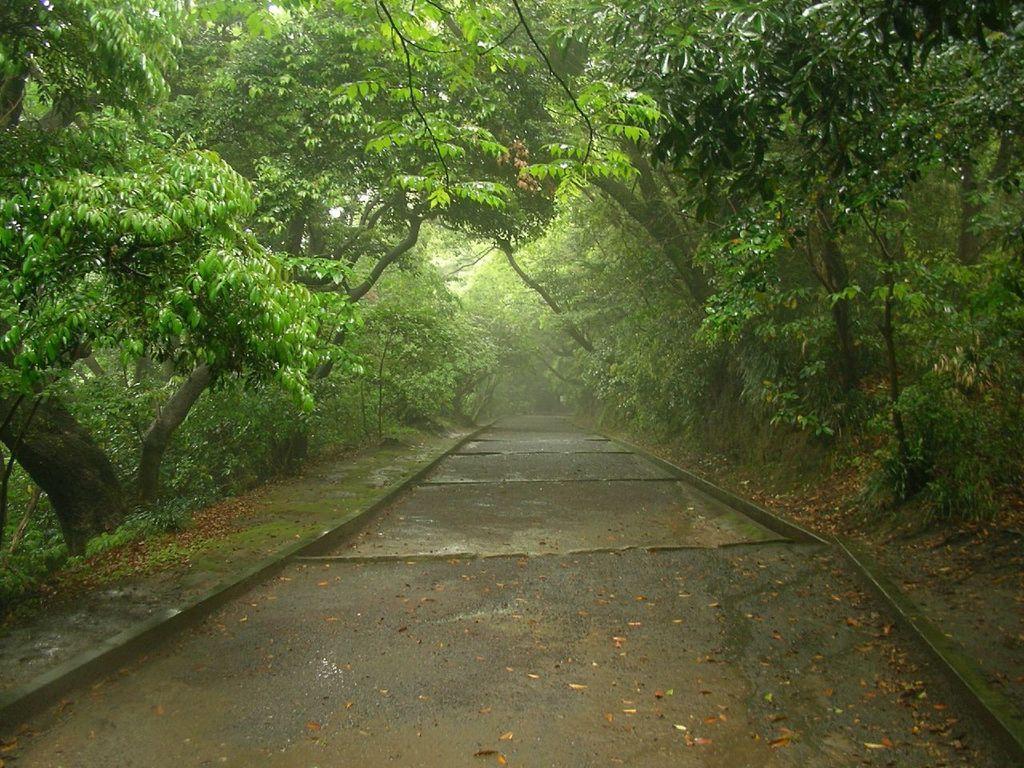Please provide a concise description of this image. In this image we can see road. On the sides of the road there are trees. 